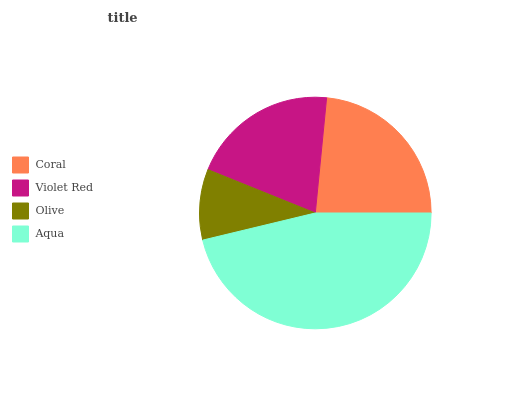Is Olive the minimum?
Answer yes or no. Yes. Is Aqua the maximum?
Answer yes or no. Yes. Is Violet Red the minimum?
Answer yes or no. No. Is Violet Red the maximum?
Answer yes or no. No. Is Coral greater than Violet Red?
Answer yes or no. Yes. Is Violet Red less than Coral?
Answer yes or no. Yes. Is Violet Red greater than Coral?
Answer yes or no. No. Is Coral less than Violet Red?
Answer yes or no. No. Is Coral the high median?
Answer yes or no. Yes. Is Violet Red the low median?
Answer yes or no. Yes. Is Olive the high median?
Answer yes or no. No. Is Olive the low median?
Answer yes or no. No. 